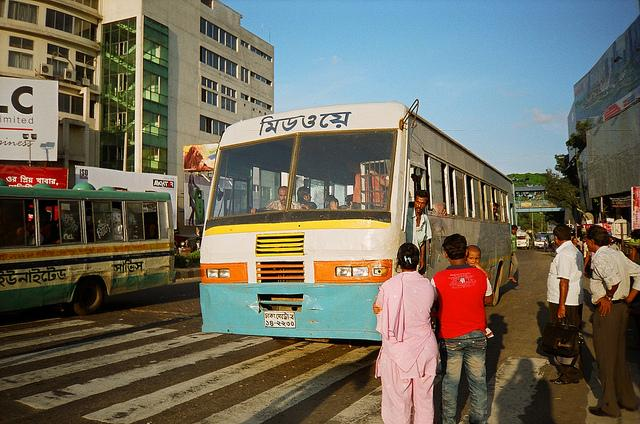What is the man with mustache about to do? get off 